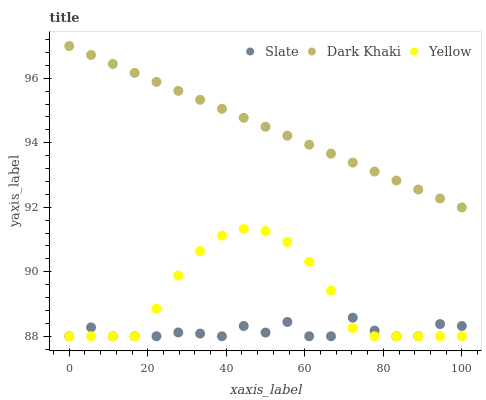Does Slate have the minimum area under the curve?
Answer yes or no. Yes. Does Dark Khaki have the maximum area under the curve?
Answer yes or no. Yes. Does Yellow have the minimum area under the curve?
Answer yes or no. No. Does Yellow have the maximum area under the curve?
Answer yes or no. No. Is Dark Khaki the smoothest?
Answer yes or no. Yes. Is Slate the roughest?
Answer yes or no. Yes. Is Yellow the smoothest?
Answer yes or no. No. Is Yellow the roughest?
Answer yes or no. No. Does Slate have the lowest value?
Answer yes or no. Yes. Does Dark Khaki have the highest value?
Answer yes or no. Yes. Does Yellow have the highest value?
Answer yes or no. No. Is Yellow less than Dark Khaki?
Answer yes or no. Yes. Is Dark Khaki greater than Slate?
Answer yes or no. Yes. Does Slate intersect Yellow?
Answer yes or no. Yes. Is Slate less than Yellow?
Answer yes or no. No. Is Slate greater than Yellow?
Answer yes or no. No. Does Yellow intersect Dark Khaki?
Answer yes or no. No. 